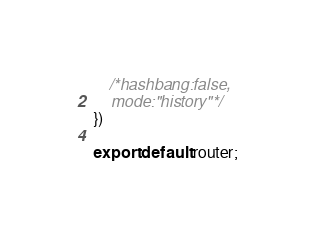<code> <loc_0><loc_0><loc_500><loc_500><_JavaScript_>    /*hashbang:false,
    mode:"history"*/
})

export default router;
</code> 